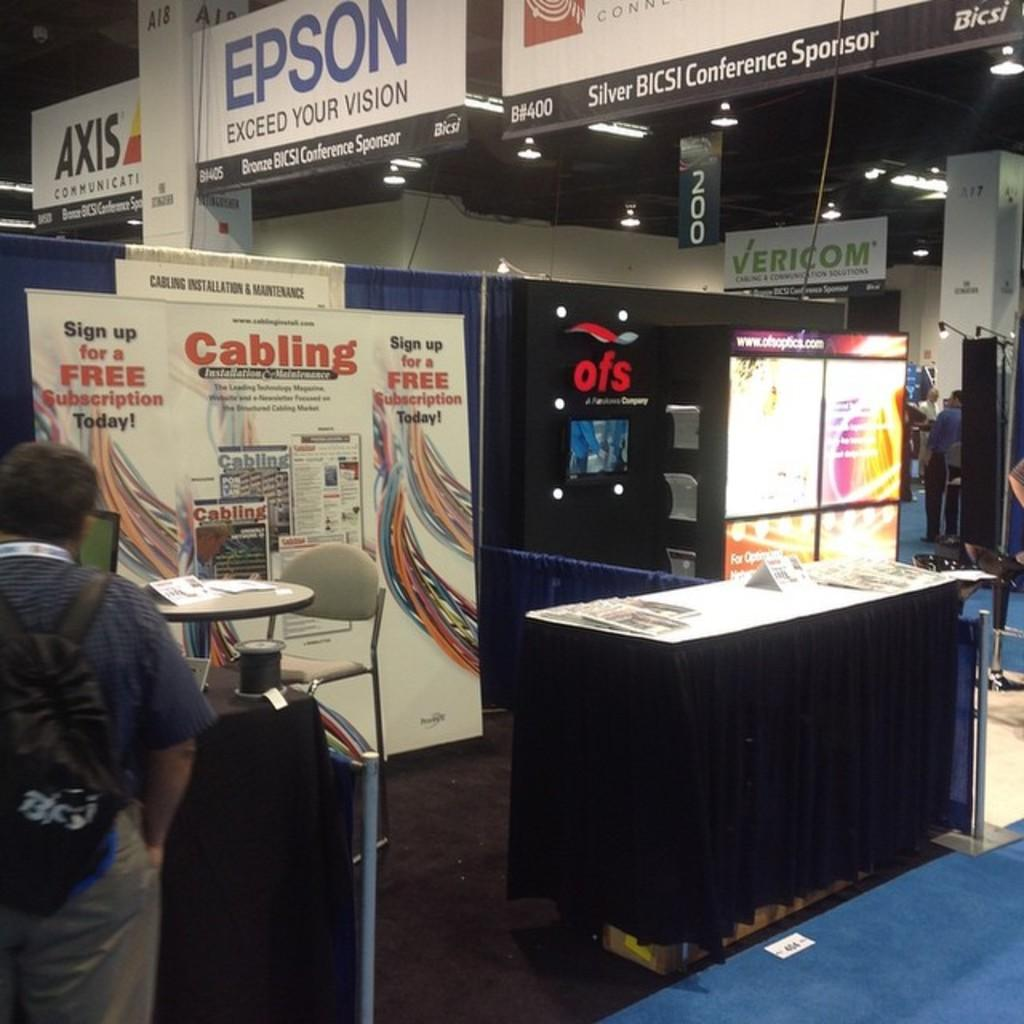What is the position of the man in the image? The man is standing on the left side of the image. What type of furniture can be seen in the image? There are chairs and a table in the image. What decorative elements are present in the image? There are banners and a sign board in the image. What architectural feature is visible in the image? There is a pillar in the image. What type of structure is present in the image? There is a wall in the image. What type of lighting is present in the image? There are lights in the image. How many additional persons are present in the image? There are additional persons standing in the image. What type of shock can be seen in the image? There is no shock present in the image. What type of pipe is visible in the image? There is no pipe visible in the image. 